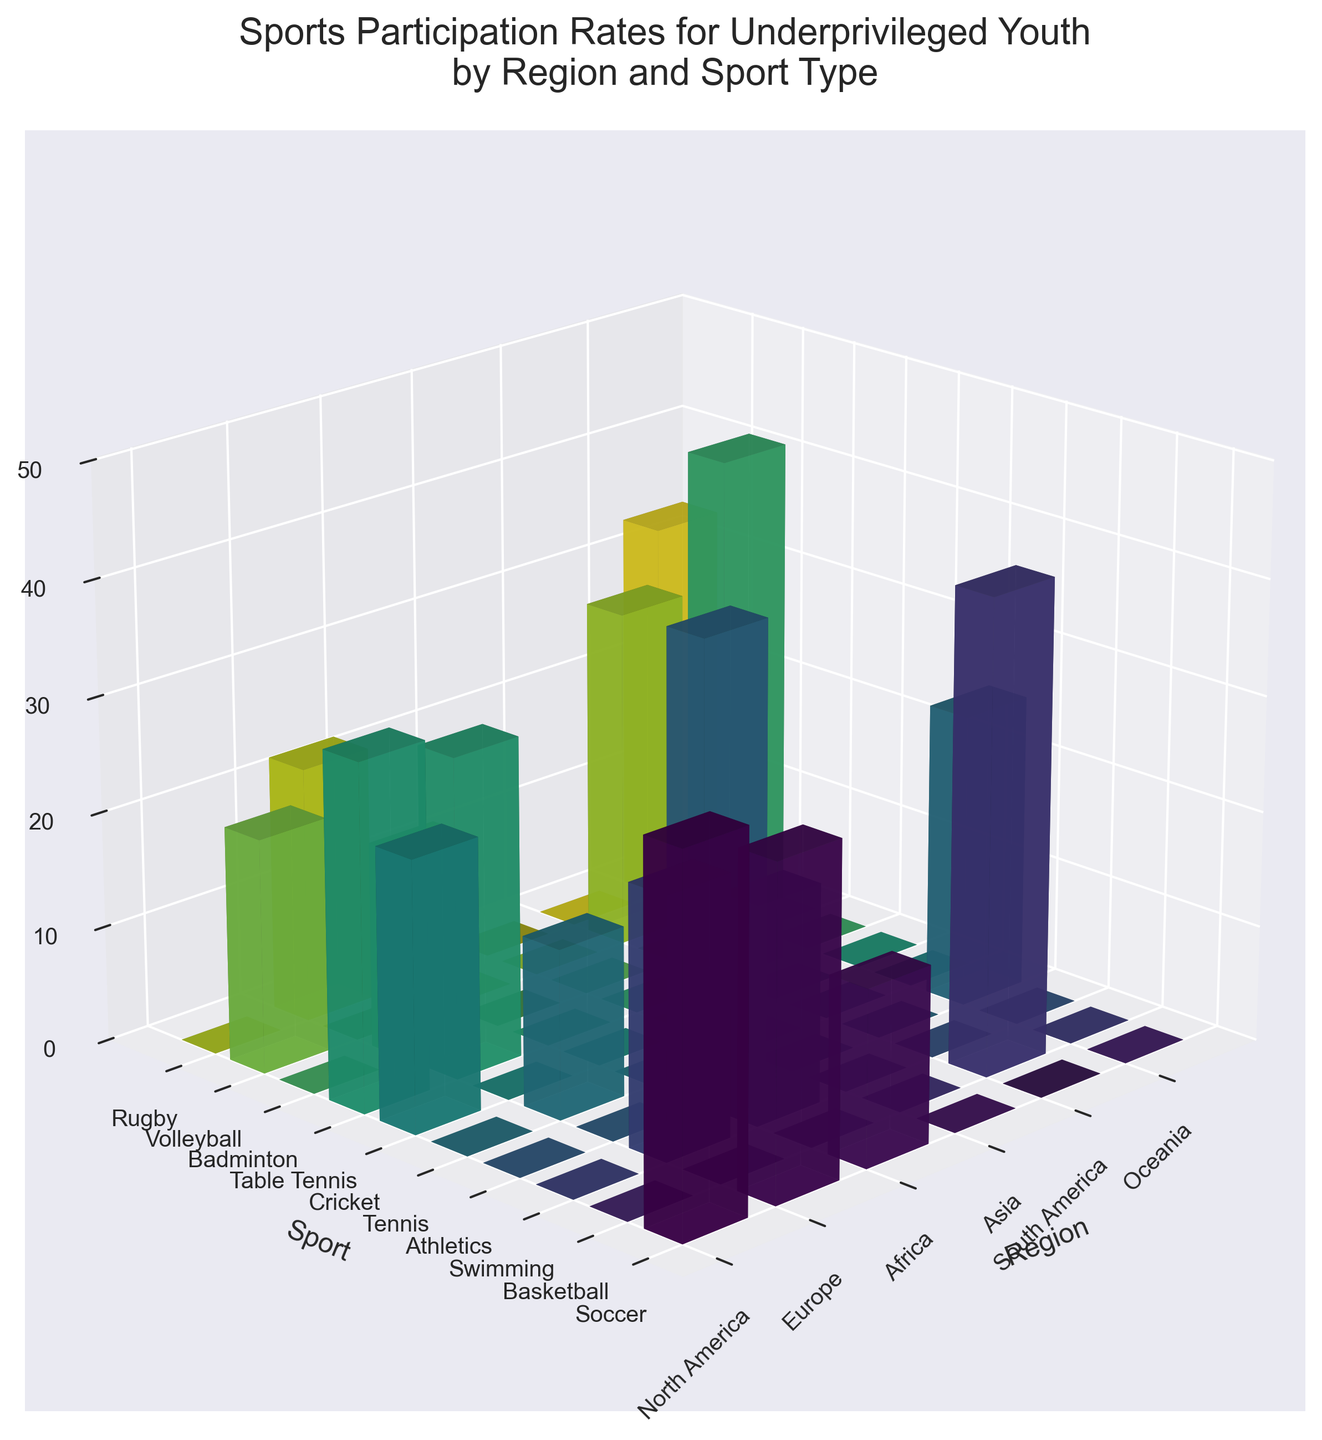What is the title of the 3D bar plot? The title of a plot is usually displayed above the figure and it provides a summary of what the plot represents. In this case, read the title provided at the top of the figure.
Answer: Sports Participation Rates for Underprivileged Youth by Region and Sport Type Which region has the highest participation rate in Soccer? Look at the bars corresponding to Soccer on the Y-axis, and find the one with the highest value. Then check the region on the X-axis corresponding to this highest value.
Answer: South America What are the regions represented in the plot? The regions are indicated on the X-axis. By observing the labels on this axis, you can list all the regions.
Answer: North America, Europe, Africa, Asia, South America, Oceania Which sport has the least participation rate in Europe? Look at the bars for each sport in the region labeled Europe on the X-axis. Identify the bar with the lowest height and read the sport label on the Y-axis.
Answer: Tennis What's the total participation rate for Soccer across all regions? Identify the bar heights corresponding to Soccer in each region and add them up: North America (32.5) + Europe (41.2) + Africa (39.8) + Asia (23.5) + South America (45.6).
Answer: 182.6 Which sport has the most balanced participation across regions? Compare the height of the bars for each sport across different regions. The sport has the most even heights for bars across various regions.
Answer: Soccer Is there any sport that has participation in every region? Check for each sport and see if all regions have a non-zero bar height for that specific sport. Soccer appears to have participation in every region.
Answer: Yes, Soccer Which region has the highest overall participation in all sports combined? Sum the heights of all bars in each region. The region with the highest total sum is North America (32.5+28.7+15.3), Europe (41.2+22.6+18.9), Africa (39.8+25.4+14.7), Asia (30.1+27.8+23.5), South America (45.6+20.3+17.8), Oceania (33.2+29.5+22.1). You need a total sum for each region.
Answer: South America How does the participation in Swimming in Oceania compare with North America? Compare the bar heights corresponding to Swimming for Oceania and North America. The bar heights are 29.5 for Oceania and 15.3 for North America.
Answer: Swimming participation in Oceania is higher Which region has the lowest participation in a sport and what is that sport? Identify the bar with the lowest height across all regions and sports. The lowest value is 14.7 for Cricket in Africa.
Answer: Africa, Cricket 